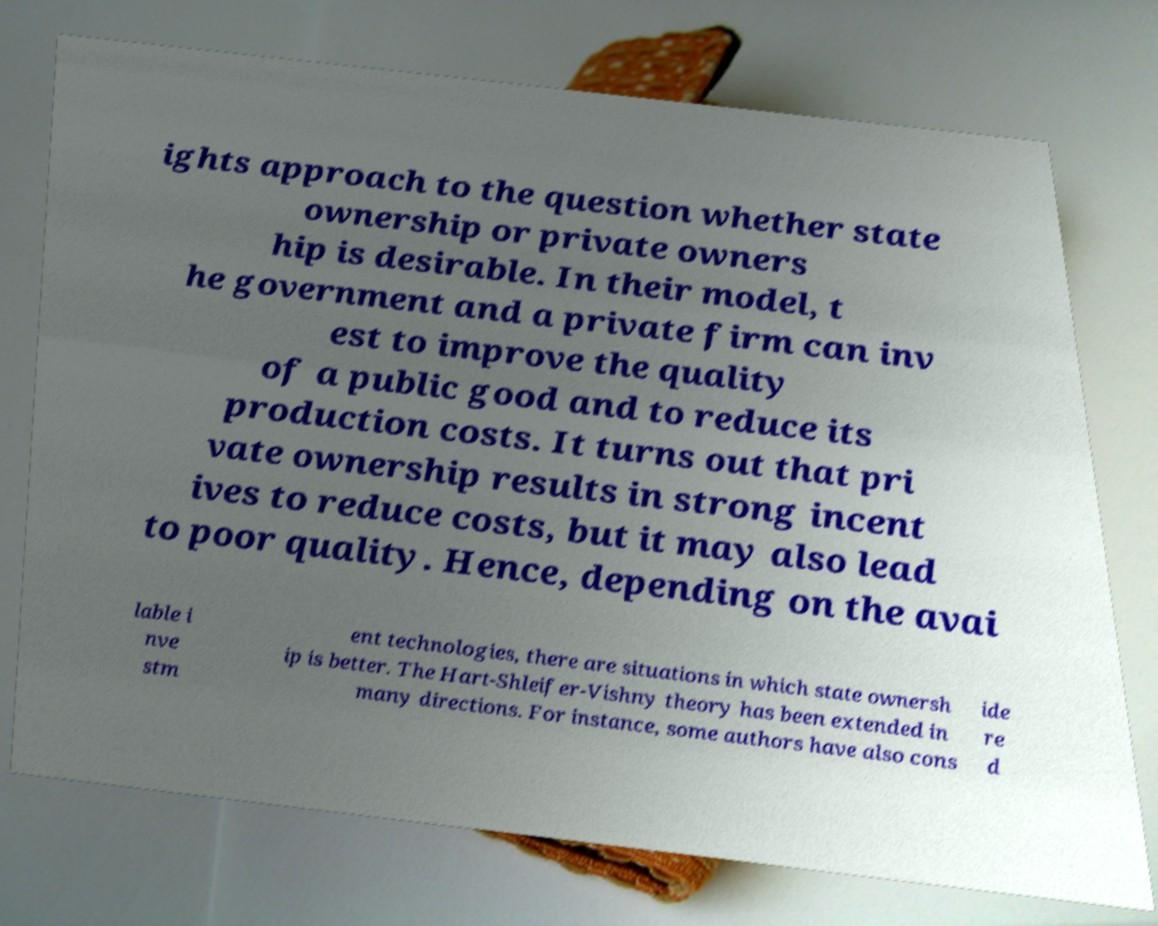Could you assist in decoding the text presented in this image and type it out clearly? ights approach to the question whether state ownership or private owners hip is desirable. In their model, t he government and a private firm can inv est to improve the quality of a public good and to reduce its production costs. It turns out that pri vate ownership results in strong incent ives to reduce costs, but it may also lead to poor quality. Hence, depending on the avai lable i nve stm ent technologies, there are situations in which state ownersh ip is better. The Hart-Shleifer-Vishny theory has been extended in many directions. For instance, some authors have also cons ide re d 